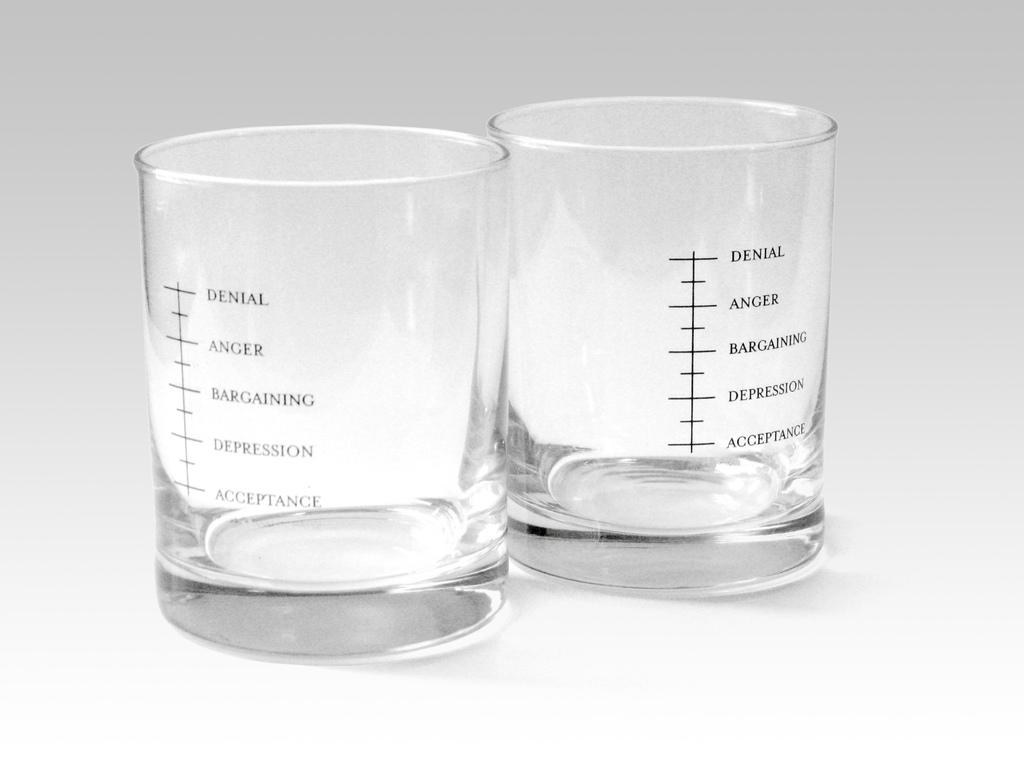<image>
Summarize the visual content of the image. Two small shot glasses contain a series of emotions on the side. 